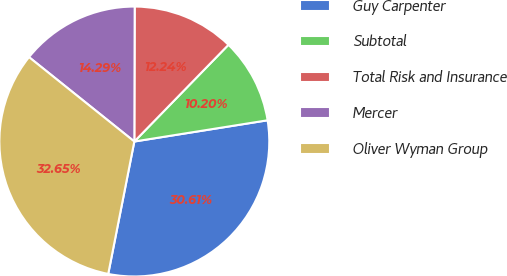Convert chart to OTSL. <chart><loc_0><loc_0><loc_500><loc_500><pie_chart><fcel>Guy Carpenter<fcel>Subtotal<fcel>Total Risk and Insurance<fcel>Mercer<fcel>Oliver Wyman Group<nl><fcel>30.61%<fcel>10.2%<fcel>12.24%<fcel>14.29%<fcel>32.65%<nl></chart> 